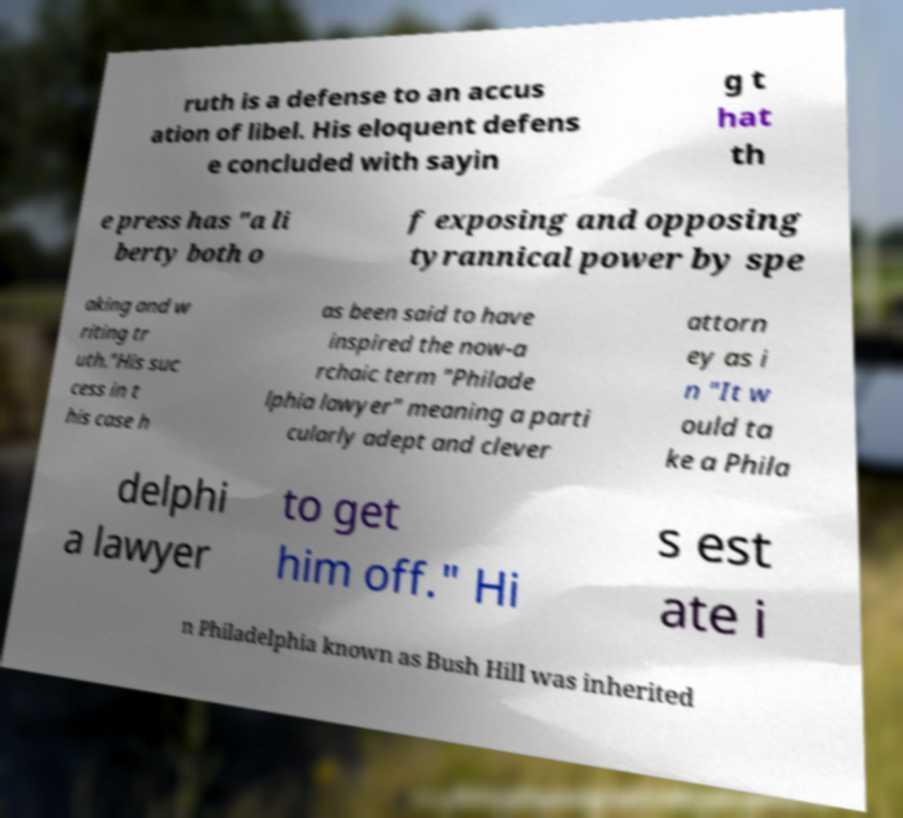Could you extract and type out the text from this image? ruth is a defense to an accus ation of libel. His eloquent defens e concluded with sayin g t hat th e press has "a li berty both o f exposing and opposing tyrannical power by spe aking and w riting tr uth."His suc cess in t his case h as been said to have inspired the now-a rchaic term "Philade lphia lawyer" meaning a parti cularly adept and clever attorn ey as i n "It w ould ta ke a Phila delphi a lawyer to get him off." Hi s est ate i n Philadelphia known as Bush Hill was inherited 